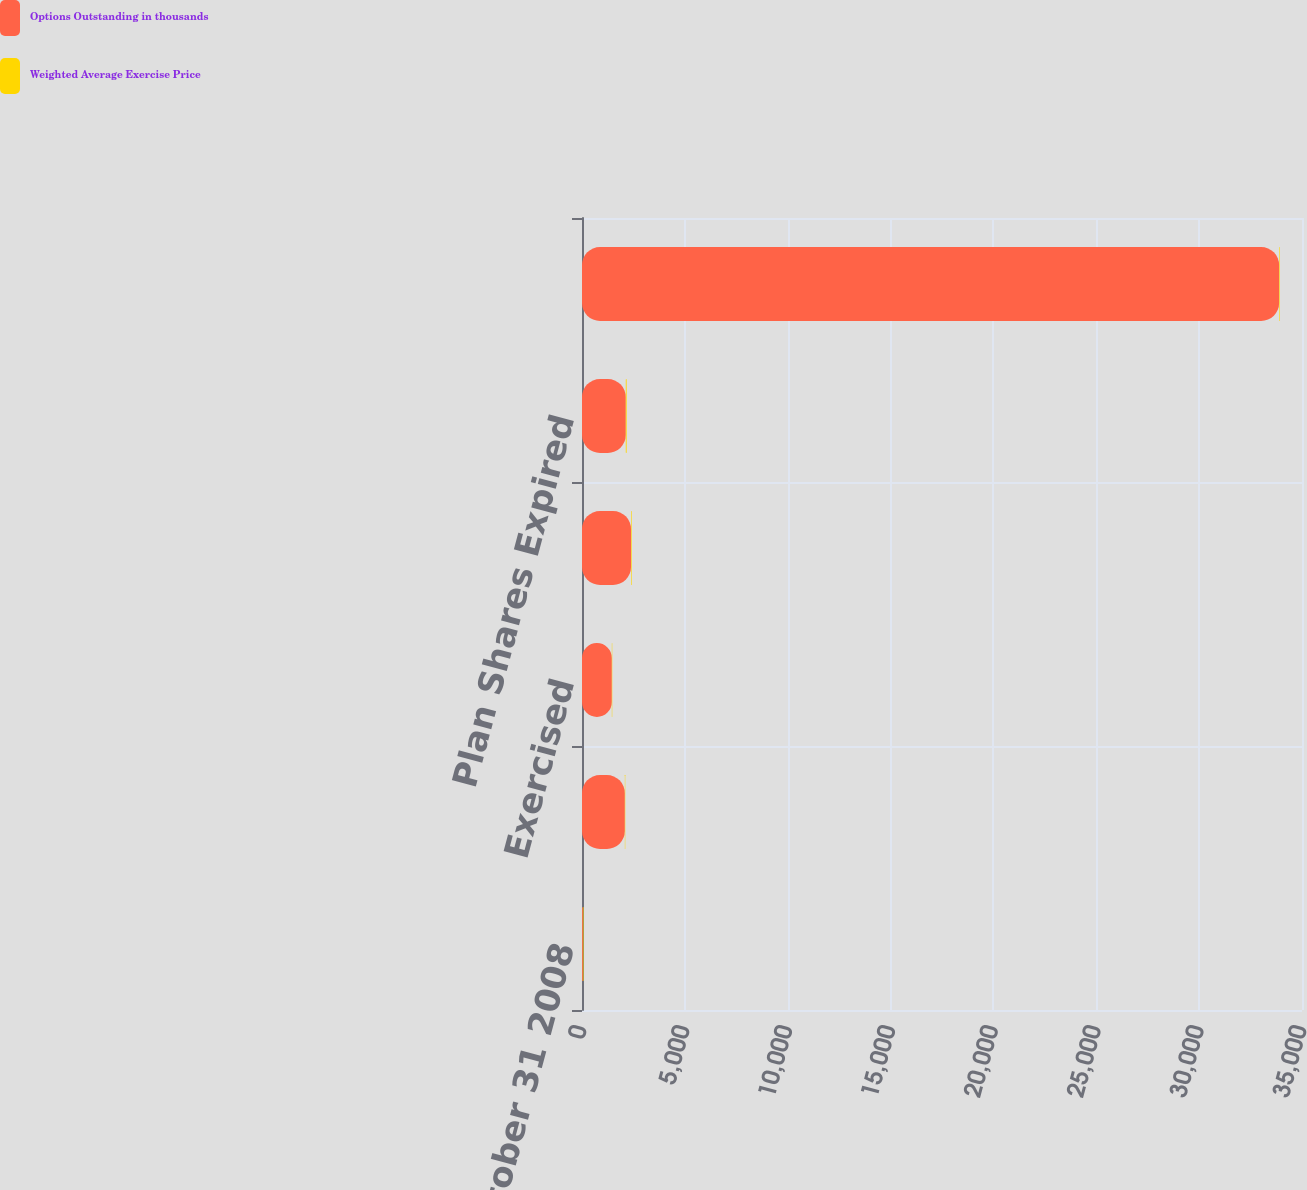<chart> <loc_0><loc_0><loc_500><loc_500><stacked_bar_chart><ecel><fcel>Outstanding at October 31 2008<fcel>Granted<fcel>Exercised<fcel>Cancelled/Forfeited/Expired<fcel>Plan Shares Expired<fcel>Outstanding at October 31 2009<nl><fcel>Options Outstanding in thousands<fcel>42<fcel>2083<fcel>1450<fcel>2383<fcel>2128<fcel>33888<nl><fcel>Weighted Average Exercise Price<fcel>29<fcel>19<fcel>20<fcel>30<fcel>42<fcel>28<nl></chart> 